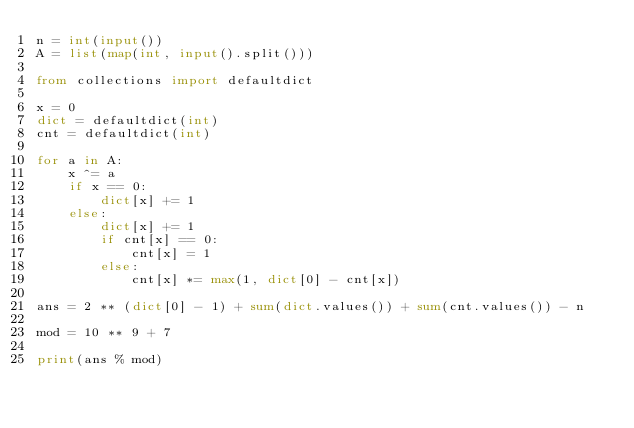<code> <loc_0><loc_0><loc_500><loc_500><_Python_>n = int(input())
A = list(map(int, input().split()))

from collections import defaultdict

x = 0
dict = defaultdict(int)
cnt = defaultdict(int)

for a in A:
    x ^= a
    if x == 0:
        dict[x] += 1
    else:
        dict[x] += 1
        if cnt[x] == 0:
            cnt[x] = 1
        else:
            cnt[x] *= max(1, dict[0] - cnt[x])

ans = 2 ** (dict[0] - 1) + sum(dict.values()) + sum(cnt.values()) - n

mod = 10 ** 9 + 7

print(ans % mod)</code> 